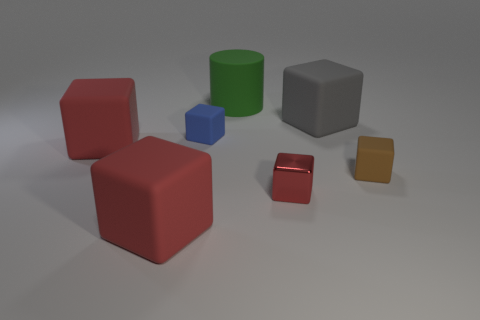Are there fewer gray cubes that are in front of the tiny red cube than big metallic cubes?
Provide a succinct answer. No. There is a tiny matte block on the right side of the blue object; how many tiny metal blocks are in front of it?
Give a very brief answer. 1. There is a matte object that is in front of the small blue cube and to the right of the green cylinder; what is its size?
Offer a very short reply. Small. Is there any other thing that has the same material as the tiny red thing?
Your response must be concise. No. Is the material of the brown thing the same as the large block right of the small blue matte object?
Offer a very short reply. Yes. Are there fewer large green matte cylinders to the right of the tiny blue matte thing than gray rubber things that are in front of the small red thing?
Your answer should be compact. No. What material is the small cube to the left of the large cylinder?
Provide a short and direct response. Rubber. The small cube that is on the right side of the small blue matte thing and to the left of the big gray matte block is what color?
Your answer should be compact. Red. What number of other things are there of the same color as the tiny metal cube?
Give a very brief answer. 2. The large cube to the right of the rubber cylinder is what color?
Make the answer very short. Gray. 